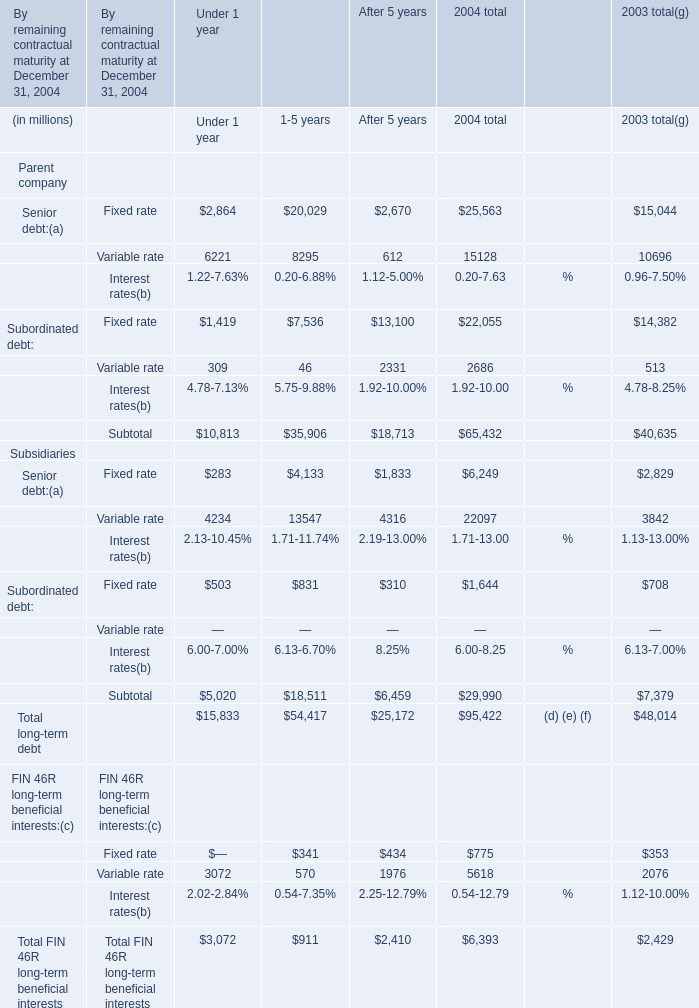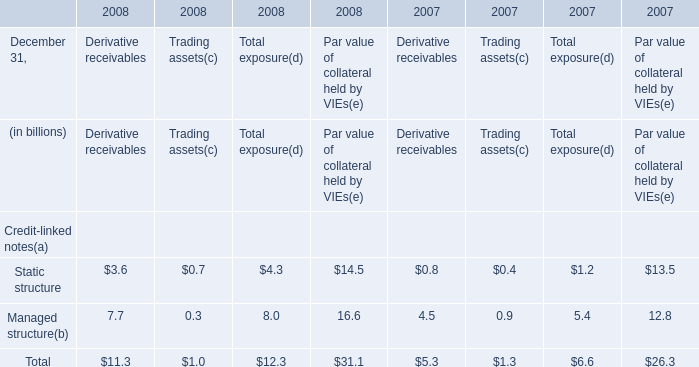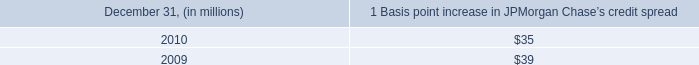what was the change in average ib and other var diversification benefit in millions during 2010? 
Computations: (59 - 82)
Answer: -23.0. 